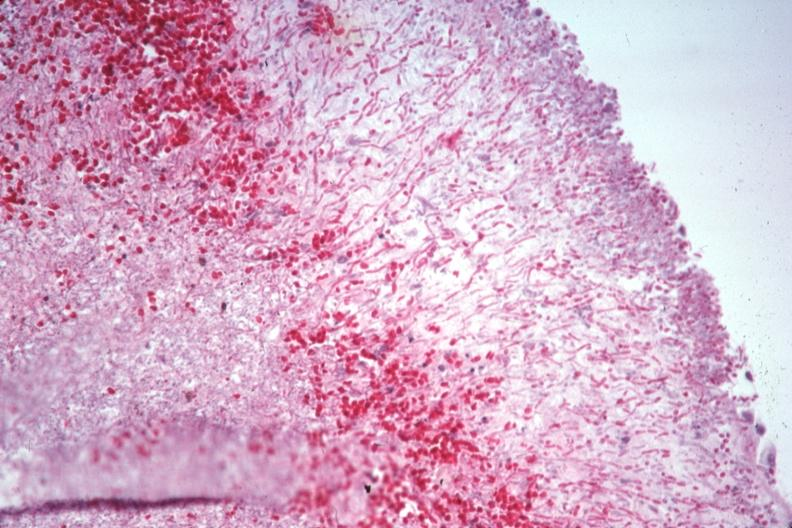what does this image show?
Answer the question using a single word or phrase. Pas large number pseudohyphae penetrating capsule which can not be recognized as spleen 